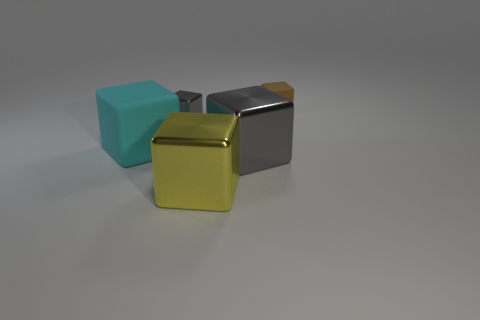There is a brown thing that is the same shape as the yellow shiny object; what is it made of?
Your answer should be compact. Rubber. How many metal blocks have the same color as the big matte block?
Your response must be concise. 0. What is the size of the yellow thing that is the same material as the tiny gray thing?
Offer a very short reply. Large. What number of cyan objects are either big things or matte things?
Offer a very short reply. 1. What number of tiny gray shiny things are left of the rubber thing that is to the left of the small brown matte cube?
Your answer should be very brief. 0. Is the number of large cyan rubber objects on the right side of the small rubber cube greater than the number of large cyan matte cubes that are in front of the big gray thing?
Give a very brief answer. No. What is the large yellow cube made of?
Provide a succinct answer. Metal. Are there any yellow metal objects that have the same size as the brown object?
Your answer should be compact. No. What is the material of the gray block that is the same size as the yellow object?
Your answer should be compact. Metal. How many things are there?
Your answer should be compact. 5. 